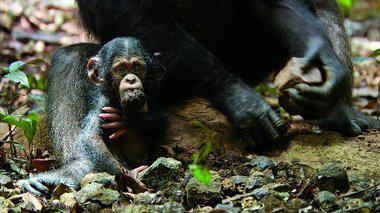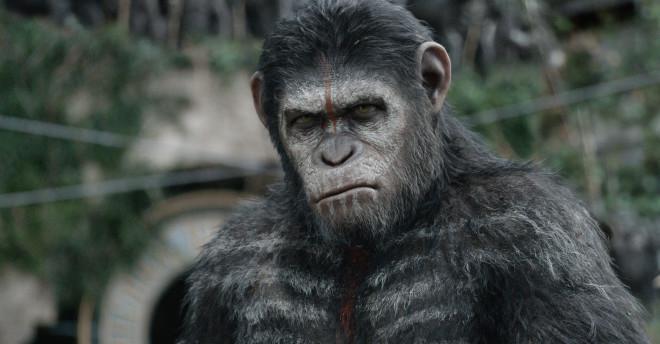The first image is the image on the left, the second image is the image on the right. Assess this claim about the two images: "There are four monkeys.". Correct or not? Answer yes or no. No. The first image is the image on the left, the second image is the image on the right. Evaluate the accuracy of this statement regarding the images: "Each image contains a pair of chimps posed near each other, and no chimps are young babies.". Is it true? Answer yes or no. No. 